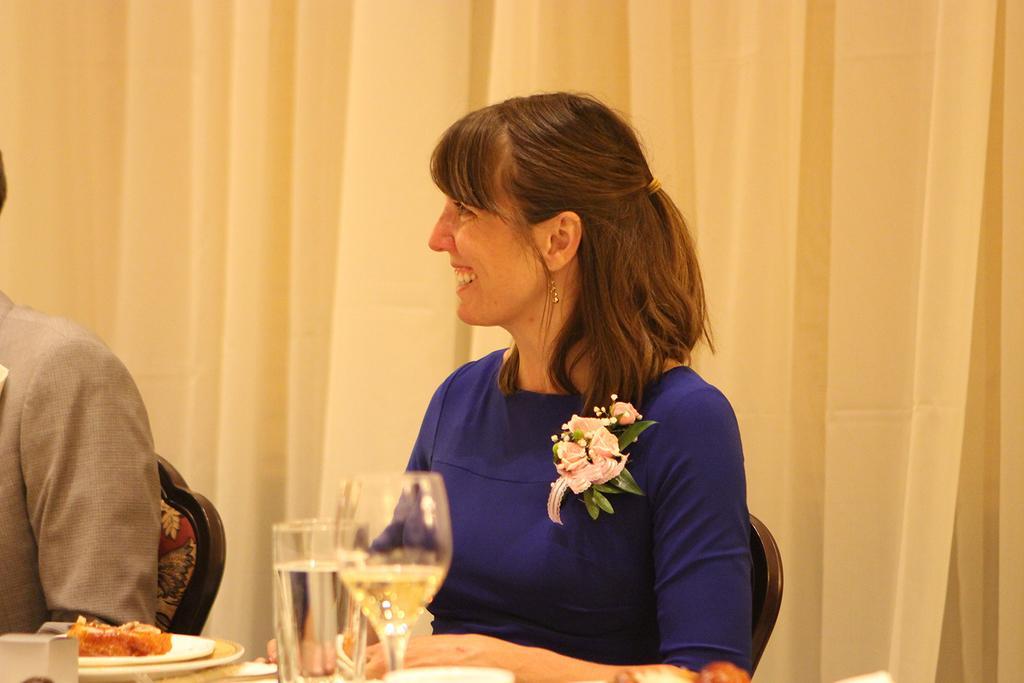How would you summarize this image in a sentence or two? In this picture we can see two persons sitting on the chairs. She is in blue color dress and there is a flower on that. And this is the table, on the table there is a plate, these are the glasses. And on the background there is a curtain. 